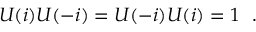<formula> <loc_0><loc_0><loc_500><loc_500>U ( i ) U ( - i ) = U ( - i ) U ( i ) = 1 \ \ .</formula> 